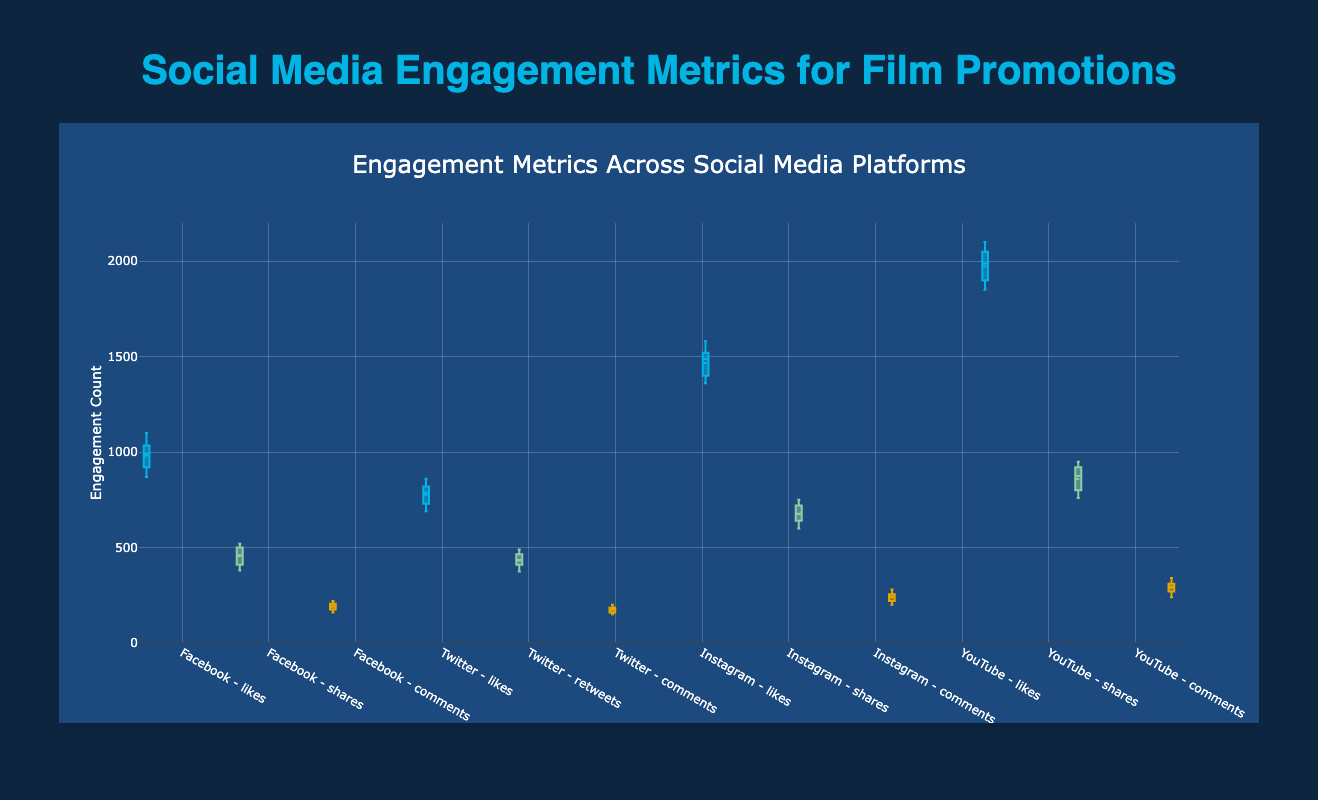What is the median number of likes on the YouTube platform? The median is the middle value when the numbers are listed in order. From the data, the numbers of likes on YouTube are listed as follows: [1850, 1880, 1900, 1920, 1980, 1995, 2000, 2050, 2060, 2100]. The median is the 5th and 6th values average since there are 10 data points: (1980 + 1995) / 2 = 1987.5
Answer: 1987.5 Which platform shows the highest median number of comments? To find this, we need to compare the median numbers of comments across all platforms. From the figure, YouTube has the highest median comments.
Answer: YouTube Which platform has the least variability in the number of likes? Variability in a box plot is indicated by the size of the interquartile range (IQR), shown by the width of the box. Observing the figure, Twitter seems to have the smallest IQR for likes, suggesting the least variability.
Answer: Twitter What is the interquartile range (IQR) of shares on Facebook? The IQR is the difference between the third quartile (Q3) and the first quartile (Q1). From the figure, Q3 for Facebook shares is approximately 500 and Q1 is around 410. Therefore, IQR = 500 - 410 = 90
Answer: 90 Which metric has a higher range, likes on Instagram or shares on YouTube? The range is the difference between the maximum and minimum values. From the figure, range for Instagram likes is 1580 - 1360 = 220, and for YouTube shares is 950 - 760 = 190. Therefore, Instagram likes have a higher range.
Answer: Instagram likes Are the median numbers of comments for Facebook and Twitter the same? To answer this, we compare the median lines in the box plots for Facebook and Twitter comments. The medians are different; Facebook’s median is around 190 and Twitter’s is around 175.
Answer: No Which platform has the greatest number of likes at the 75th percentile? The 75th percentile value is indicated by the top of the box. Observing the figure, YouTube has the highest value at the 75th percentile for likes.
Answer: YouTube What is the difference in the median number of likes between Facebook and Instagram? The median number of likes for Facebook is around 1000 and for Instagram is around 1500. The difference is 1500 - 1000 = 500
Answer: 500 Which platform's engagement metric shows the most consistent comment counts? Consistency can be assessed by identifying the narrowest IQR for comments. Twitter displays the most consistent comment counts, indicated by the smallest IQR on its box plot for comments.
Answer: Twitter 